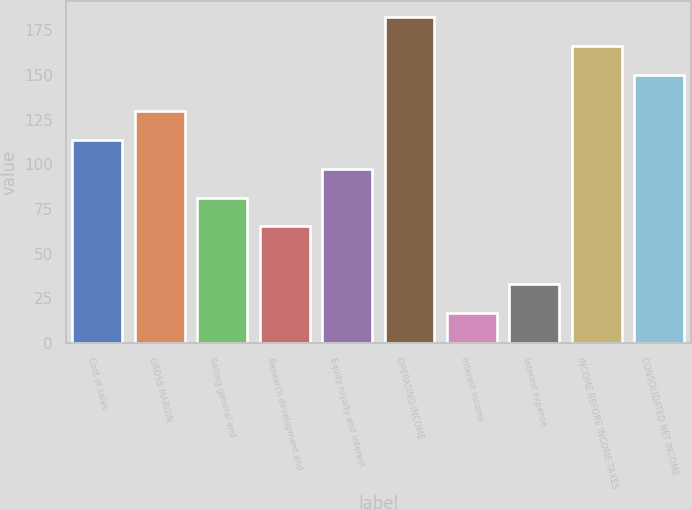Convert chart. <chart><loc_0><loc_0><loc_500><loc_500><bar_chart><fcel>Cost of sales<fcel>GROSS MARGIN<fcel>Selling general and<fcel>Research development and<fcel>Equity royalty and interest<fcel>OPERATING INCOME<fcel>Interest income<fcel>Interest expense<fcel>INCOME BEFORE INCOME TAXES<fcel>CONSOLIDATED NET INCOME<nl><fcel>113.6<fcel>129.72<fcel>81.36<fcel>65.24<fcel>97.48<fcel>182.24<fcel>16.88<fcel>33<fcel>166.12<fcel>150<nl></chart> 